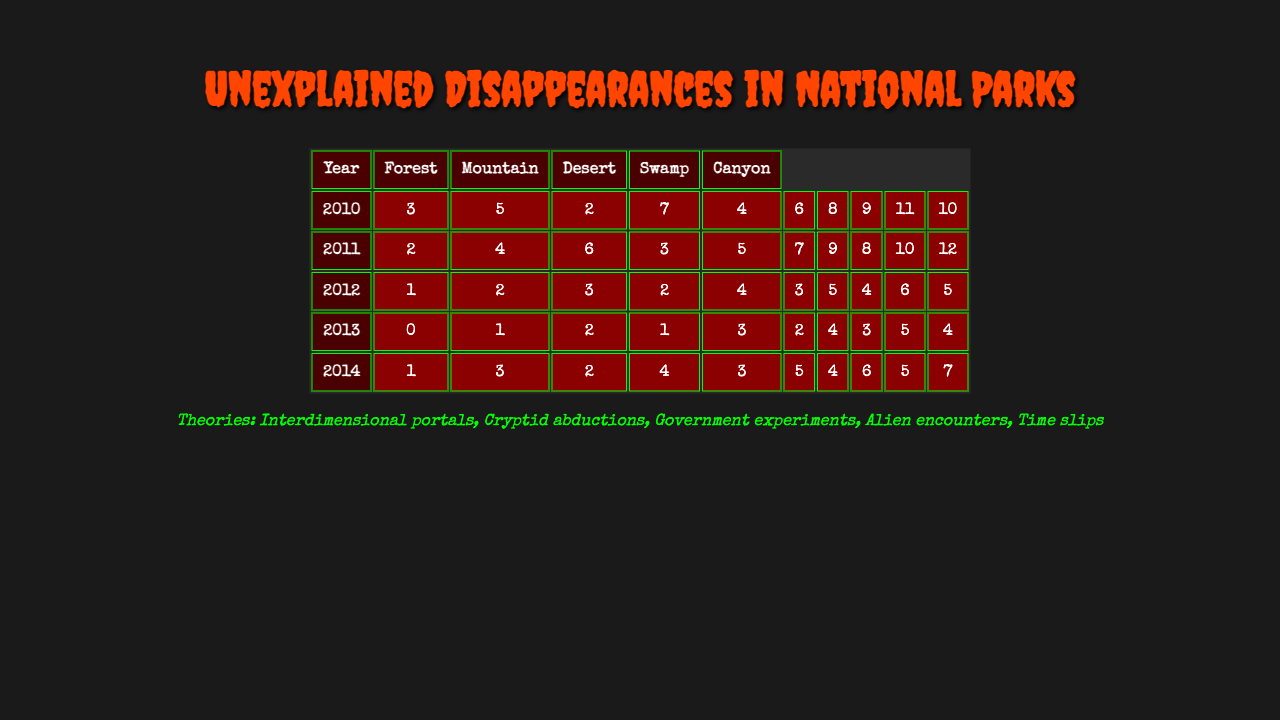What was the highest number of disappearances recorded in 2019? Referring to the 2019 row for each terrain, the numbers are 10, 12, 5, 4, and 7. The highest among these is 12.
Answer: 12 Which terrain type had the lowest total number of disappearances across all years? Summing the totals for each terrain: Forest (66), Mountain (66), Desert (30), Swamp (22), Canyon (33). The lowest is Swamp with 22.
Answer: Swamp In which year did disappearances peak for the Forest terrain? Looking at the Forest row, the highest number is 11 in 2018.
Answer: 2018 What is the average number of disappearances for Canyon terrain from 2010 to 2019? Summing the Canyon values (4 + 3 + 4 + 1 + 4 + 6 + 5 + 5 + 7 + 6) gives 45. With 10 years of data, the average is 45 / 10 = 4.5.
Answer: 4.5 Did the number of disappearances for the Desert terrain increase consistently every year? Checking the Desert terrain values: 2, 6, 3, 4, 4, 5, 6, 5, 6, 5 shows fluctuations, not a consistent increase.
Answer: No What were the disappearances like in 2015 compared to 2016 across all terrains? For 2015: Forest had 6, Mountain 7, Desert 3, Swamp 2, Canyon 5 (Total = 23). For 2016: Forest had 8, Mountain 9, Desert 5, Swamp 4, Canyon 4 (Total = 30). Total disappearances increased from 23 to 30.
Answer: Increased Which terrain saw the most significant difference in disappearances from 2011 to 2012? Calculating the differences for each terrain: Forest (2), Mountain (2), Desert (1), Swamp (1), Canyon (1). The greatest difference is for both Forest and Mountain, which had a decrease of 2.
Answer: Forest and Mountain How many total unexplained disappearances occurred in the Mountain terrain over the years presented in the table? The numbers for Mountain across the years are 5, 4, 6, 3, 5, 7, 9, 8, 10, 12, which totals 69.
Answer: 69 For which specific year did Swamp disappearances show the highest single count? Inspecting the Swamp terrain row, the highest value is 5 occurring in 2018.
Answer: 2018 Is there a year where the Forest terrain recorded fewer disappearances than the Swamp terrain? After comparing years, 2013 shows Forest at 3 while Swamp at 1. So, Forest had more disappearances than Swamp.
Answer: No 